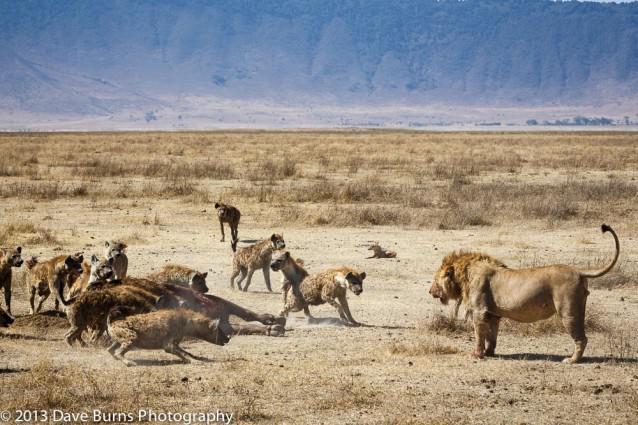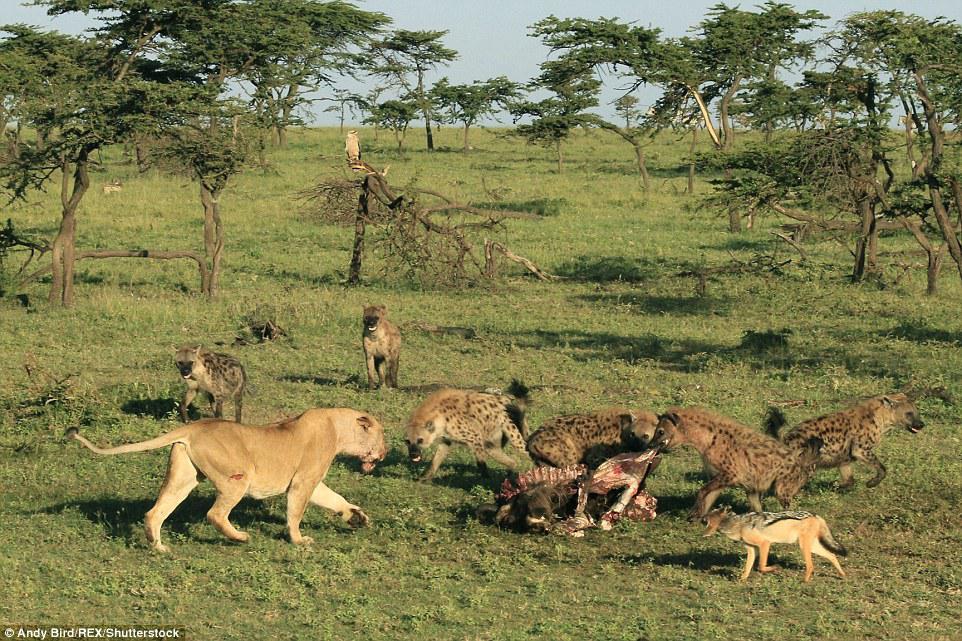The first image is the image on the left, the second image is the image on the right. For the images displayed, is the sentence "The image on the right shows no more than 5 cats." factually correct? Answer yes or no. No. 